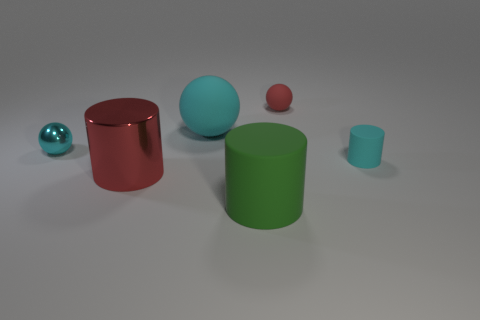How many shiny objects are brown spheres or big red things?
Offer a very short reply. 1. The big matte object that is the same shape as the big red shiny object is what color?
Your response must be concise. Green. What number of things are big matte cylinders or small red balls?
Make the answer very short. 2. There is a small red object that is made of the same material as the small cyan cylinder; what is its shape?
Make the answer very short. Sphere. What number of large things are yellow objects or cyan metal balls?
Keep it short and to the point. 0. How many other objects are the same color as the metallic cylinder?
Provide a short and direct response. 1. There is a shiny thing that is to the left of the red thing left of the big green cylinder; how many small objects are in front of it?
Your answer should be very brief. 1. There is a matte sphere that is in front of the red matte sphere; does it have the same size as the cyan shiny object?
Provide a short and direct response. No. Is the number of cyan matte objects to the left of the tiny red sphere less than the number of large cyan matte things on the right side of the big cyan object?
Provide a succinct answer. No. Does the small rubber ball have the same color as the big metal cylinder?
Provide a succinct answer. Yes. 